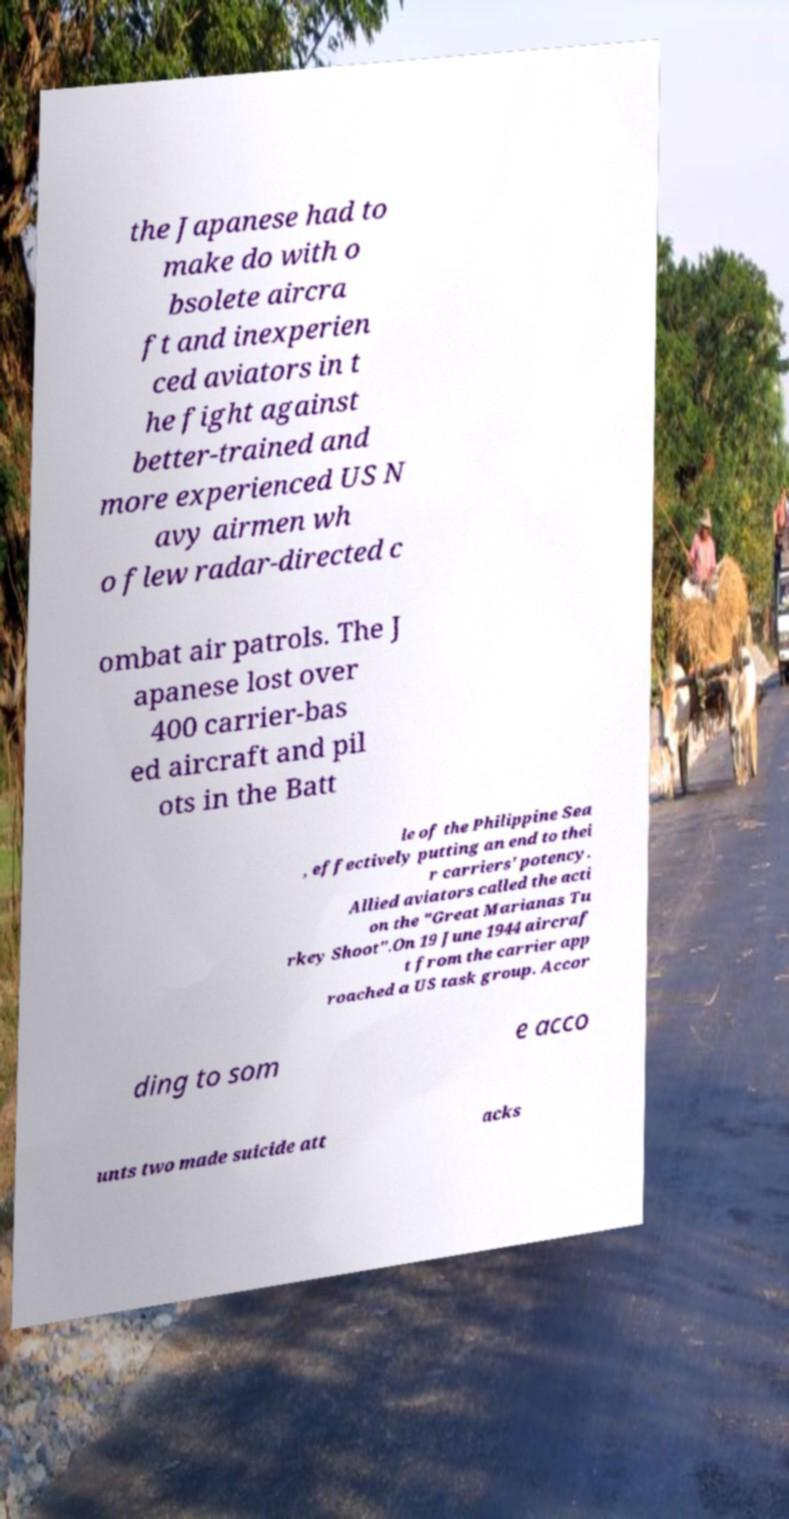I need the written content from this picture converted into text. Can you do that? the Japanese had to make do with o bsolete aircra ft and inexperien ced aviators in t he fight against better-trained and more experienced US N avy airmen wh o flew radar-directed c ombat air patrols. The J apanese lost over 400 carrier-bas ed aircraft and pil ots in the Batt le of the Philippine Sea , effectively putting an end to thei r carriers' potency. Allied aviators called the acti on the "Great Marianas Tu rkey Shoot".On 19 June 1944 aircraf t from the carrier app roached a US task group. Accor ding to som e acco unts two made suicide att acks 